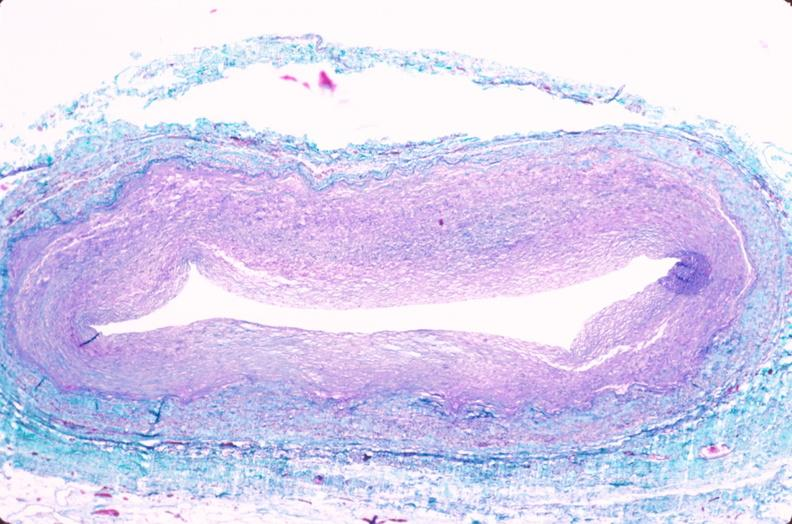s cardiovascular present?
Answer the question using a single word or phrase. Yes 